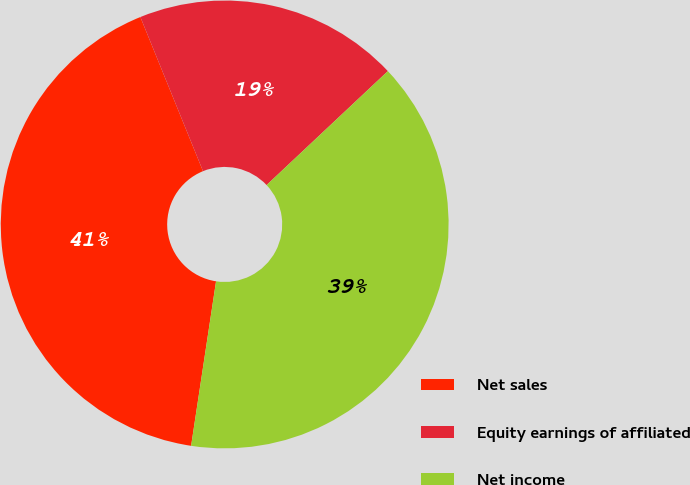Convert chart to OTSL. <chart><loc_0><loc_0><loc_500><loc_500><pie_chart><fcel>Net sales<fcel>Equity earnings of affiliated<fcel>Net income<nl><fcel>41.46%<fcel>19.14%<fcel>39.4%<nl></chart> 